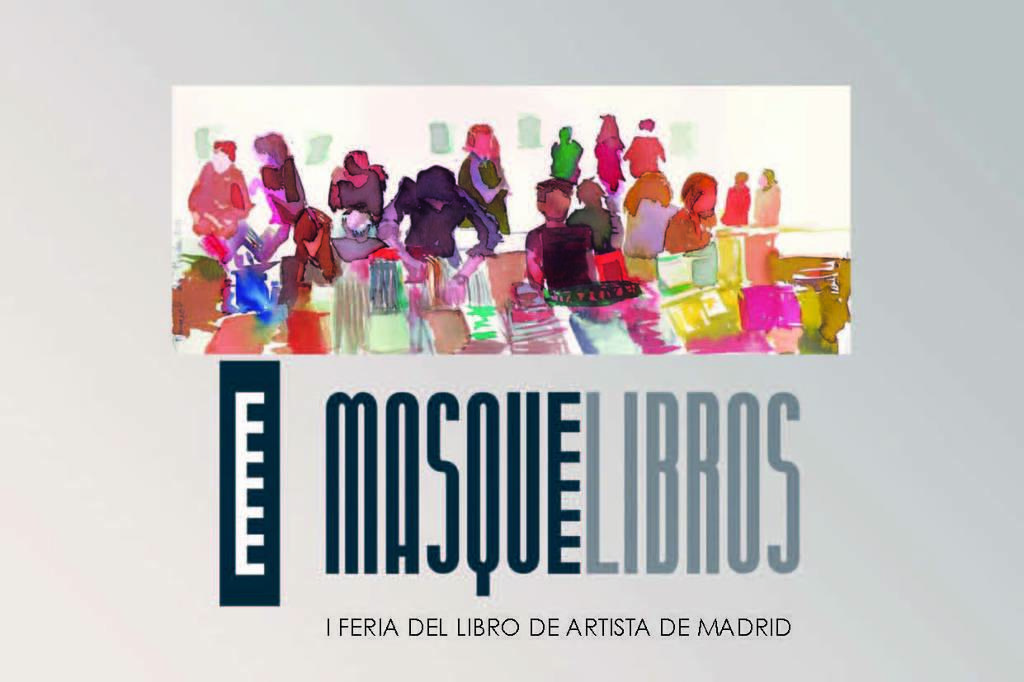What does it say on the poster?
Provide a succinct answer. Masque libros. 